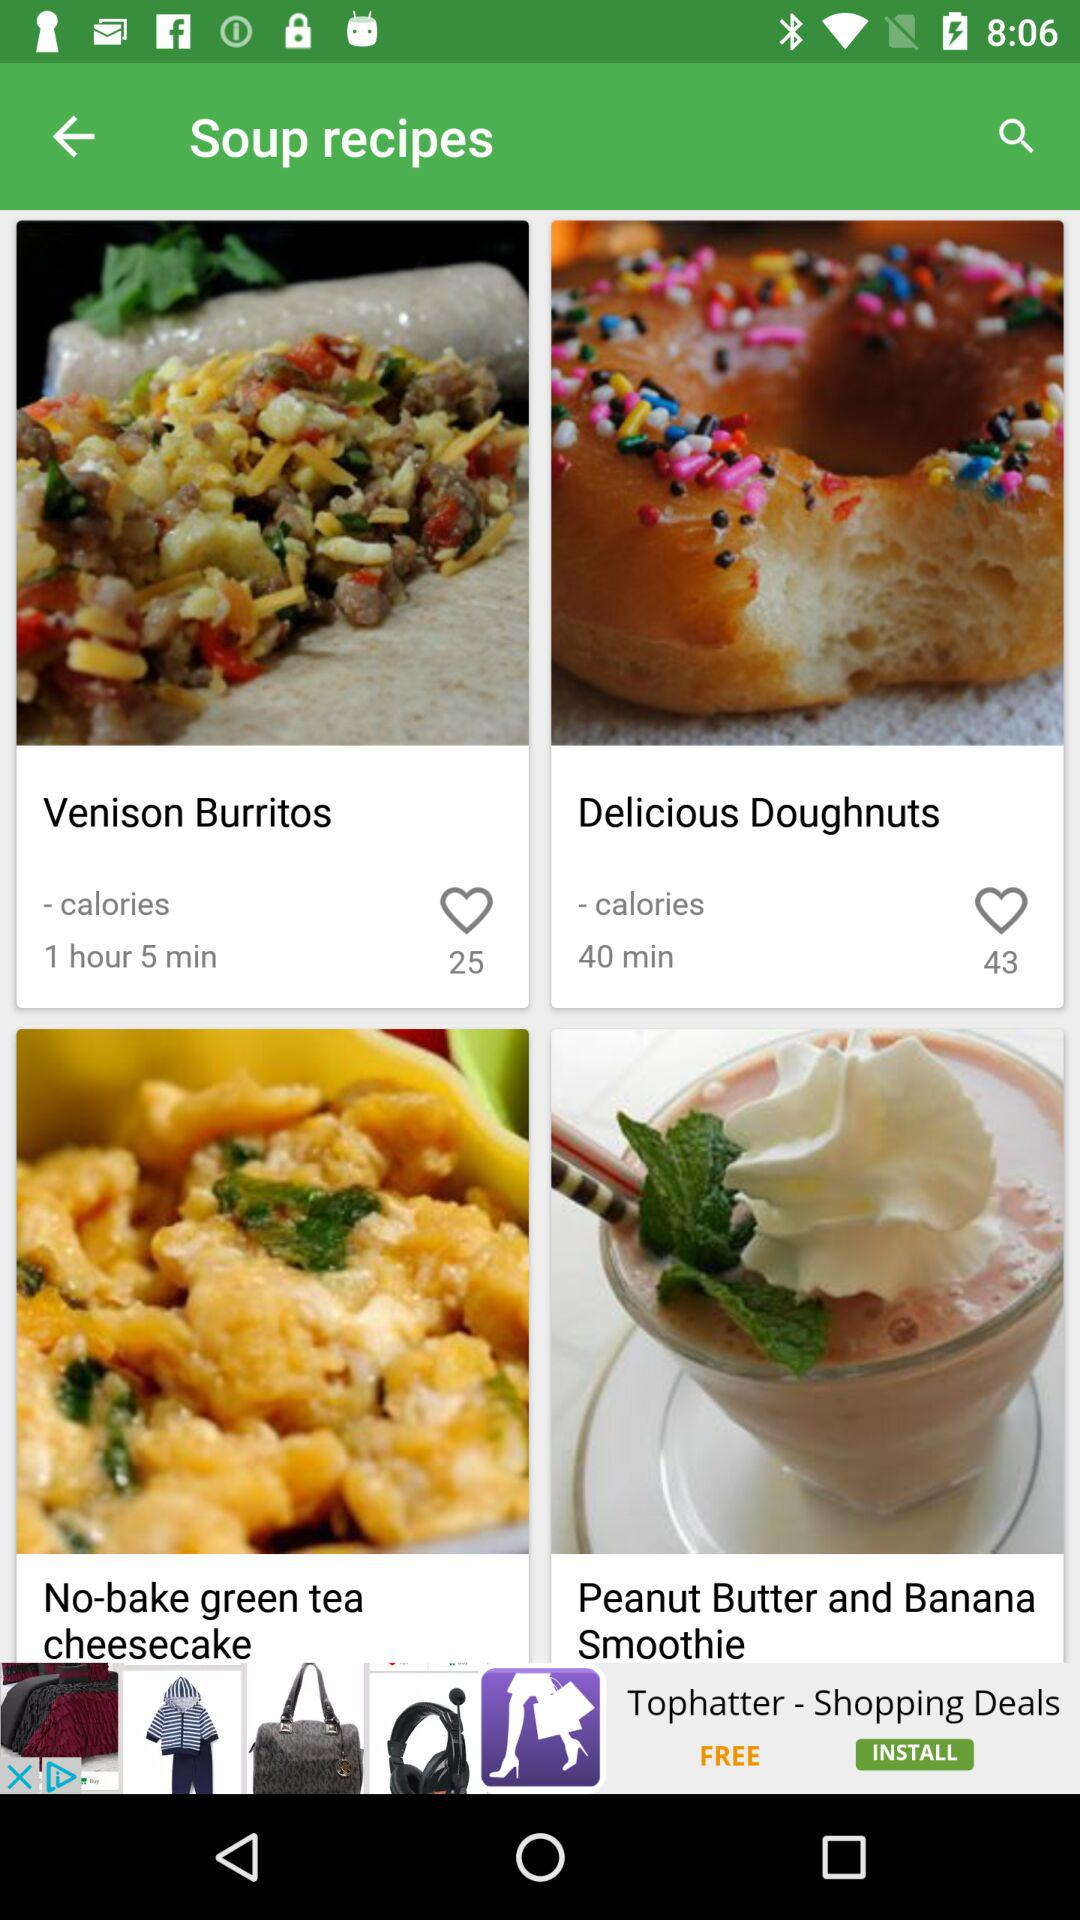How much time will it take to make the "Venison Burritos"?
Answer the question using a single word or phrase. It will take 1 hour 5 minutes to make the "Venison Burritos" 